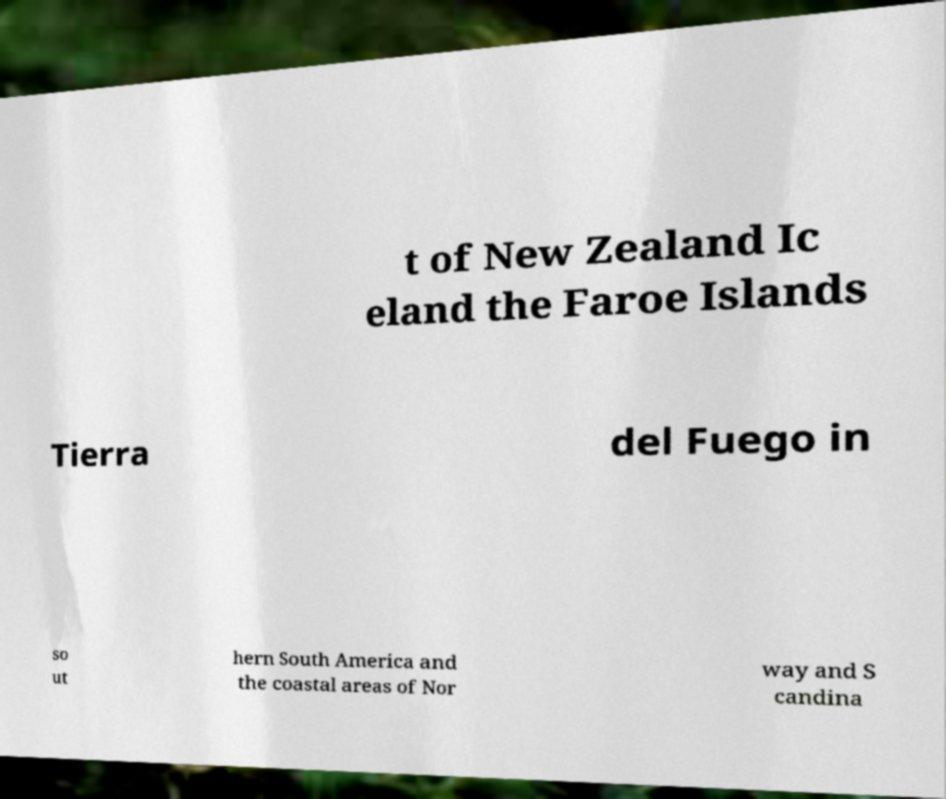Please read and relay the text visible in this image. What does it say? t of New Zealand Ic eland the Faroe Islands Tierra del Fuego in so ut hern South America and the coastal areas of Nor way and S candina 